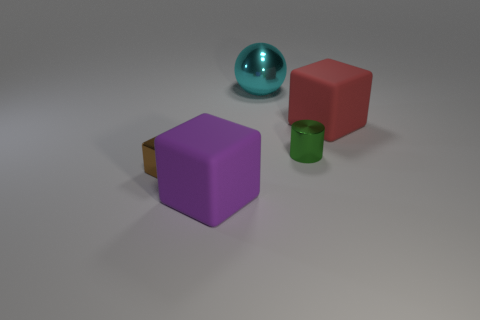Subtract all rubber blocks. How many blocks are left? 1 Add 5 small cubes. How many objects exist? 10 Subtract all cylinders. How many objects are left? 4 Add 1 large red matte blocks. How many large red matte blocks are left? 2 Add 1 big blue shiny cylinders. How many big blue shiny cylinders exist? 1 Subtract 1 green cylinders. How many objects are left? 4 Subtract all tiny gray cubes. Subtract all large cyan balls. How many objects are left? 4 